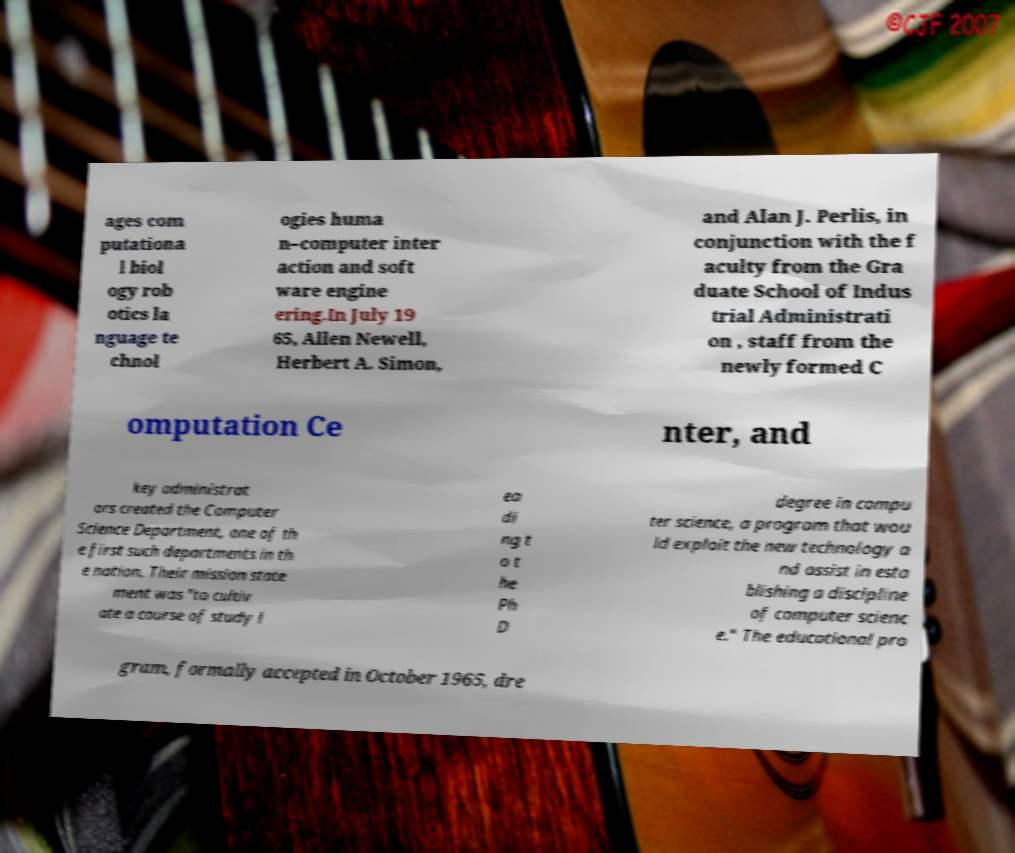There's text embedded in this image that I need extracted. Can you transcribe it verbatim? ages com putationa l biol ogy rob otics la nguage te chnol ogies huma n–computer inter action and soft ware engine ering.In July 19 65, Allen Newell, Herbert A. Simon, and Alan J. Perlis, in conjunction with the f aculty from the Gra duate School of Indus trial Administrati on , staff from the newly formed C omputation Ce nter, and key administrat ors created the Computer Science Department, one of th e first such departments in th e nation. Their mission state ment was "to cultiv ate a course of study l ea di ng t o t he Ph D degree in compu ter science, a program that wou ld exploit the new technology a nd assist in esta blishing a discipline of computer scienc e." The educational pro gram, formally accepted in October 1965, dre 